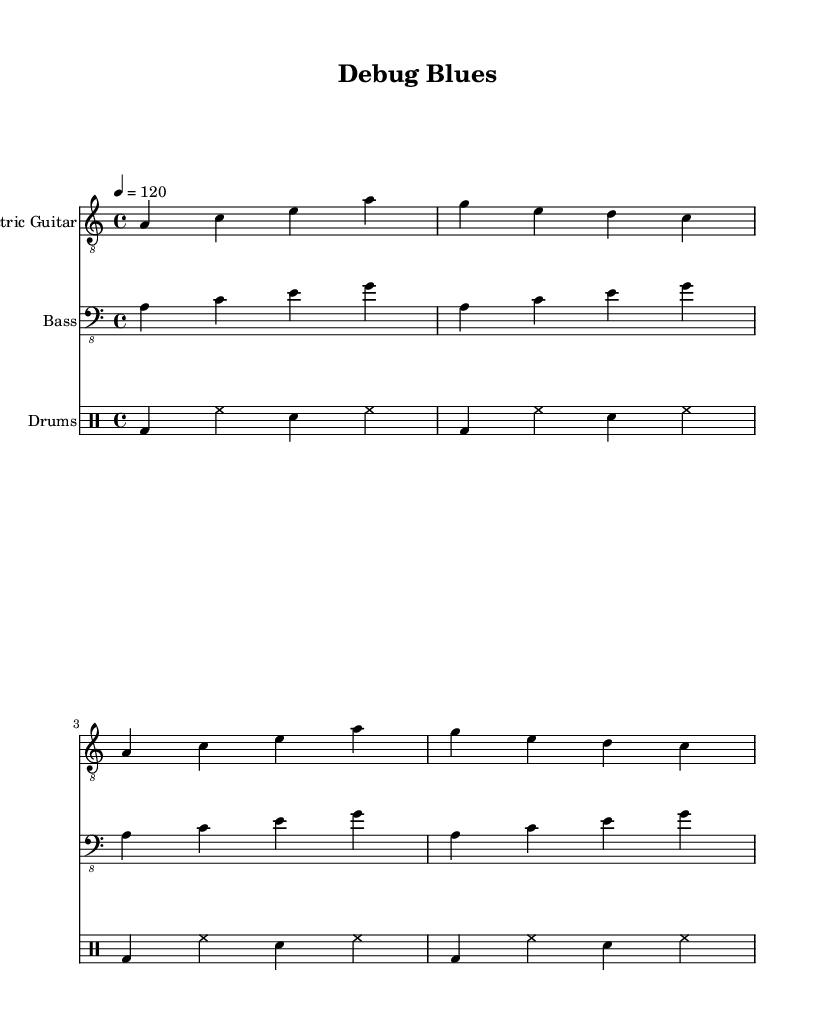What is the key signature of this music? The key signature is indicated by the absence of sharps or flats in the sheet music notation placed at the beginning of the staff. In this case, it is labeled as A minor, which has no sharps or flats.
Answer: A minor What is the time signature of this music? The time signature is displayed in the beginning part of the sheet music. It shows a "4" on top of another "4," which indicates that there are four beats in each measure and a quarter note gets one beat.
Answer: 4/4 What is the tempo marking of this music? The tempo is indicated in beats per minute, shown as "4 = 120" at the beginning of the score. This tells the performer to play the quarter note at 120 beats per minute.
Answer: 120 How many measures are in the Electric Guitar part? To find the number of measures, we count each segment between vertical lines (bar lines) in the Electric Guitar part. There are a total of four measures in the notated section for the Electric Guitar.
Answer: 4 Which instrument plays the bass line? The bass line is indicated by the staff labeled "Bass." It shows the notes positioned for the bass guitar. Therefore, the instrument playing the bass line is the bass guitar.
Answer: Bass guitar What is the rhythmic pattern of the drum part? To understand the rhythmic pattern of the drum part, one must analyze each component in the drumming notation. The given pattern consists of a bass drum on beats one and three followed by hi-hats and a snare drum, creating a consistent four-bar groove.
Answer: Bass, hi-hat, snare What do the lyrics in the song refer to? The lyrics can be interpreted by looking at the text provided under the Electric Guitar part. The phrases "Debugging all night long" and "Searching for that elusive bug" indicate that the lyrics refer to the themes of persistence and searching often experienced during coding and debugging sessions.
Answer: Coding and debugging 